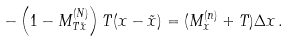<formula> <loc_0><loc_0><loc_500><loc_500>- \left ( 1 - M _ { T \tilde { x } } ^ { ( N ) } \right ) T ( x - \tilde { x } ) = ( M _ { x } ^ { ( n ) } + T ) \Delta x \, .</formula> 